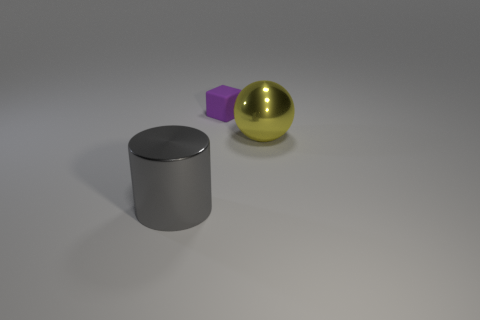What is the shape of the big gray object?
Give a very brief answer. Cylinder. Do the shiny sphere and the cylinder have the same size?
Make the answer very short. Yes. What number of other objects are there of the same shape as the tiny matte object?
Ensure brevity in your answer.  0. There is a big metallic object that is on the left side of the metallic ball; what shape is it?
Ensure brevity in your answer.  Cylinder. There is a object that is behind the big yellow object; does it have the same shape as the metal object right of the gray thing?
Ensure brevity in your answer.  No. Is the number of gray metal cylinders that are to the right of the large gray metallic thing the same as the number of metallic spheres?
Your response must be concise. No. Is there anything else that is the same size as the shiny cylinder?
Provide a succinct answer. Yes. There is a thing that is behind the big metal thing to the right of the big cylinder; what is its shape?
Offer a terse response. Cube. Is the material of the cube behind the metal sphere the same as the yellow thing?
Your answer should be compact. No. Are there the same number of gray metal objects that are in front of the large yellow ball and small rubber cubes that are on the right side of the purple matte block?
Keep it short and to the point. No. 